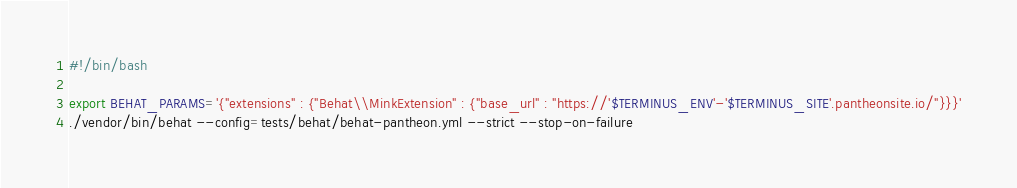Convert code to text. <code><loc_0><loc_0><loc_500><loc_500><_Bash_>#!/bin/bash

export BEHAT_PARAMS='{"extensions" : {"Behat\\MinkExtension" : {"base_url" : "https://'$TERMINUS_ENV'-'$TERMINUS_SITE'.pantheonsite.io/"}}}'
./vendor/bin/behat --config=tests/behat/behat-pantheon.yml --strict --stop-on-failure
</code> 